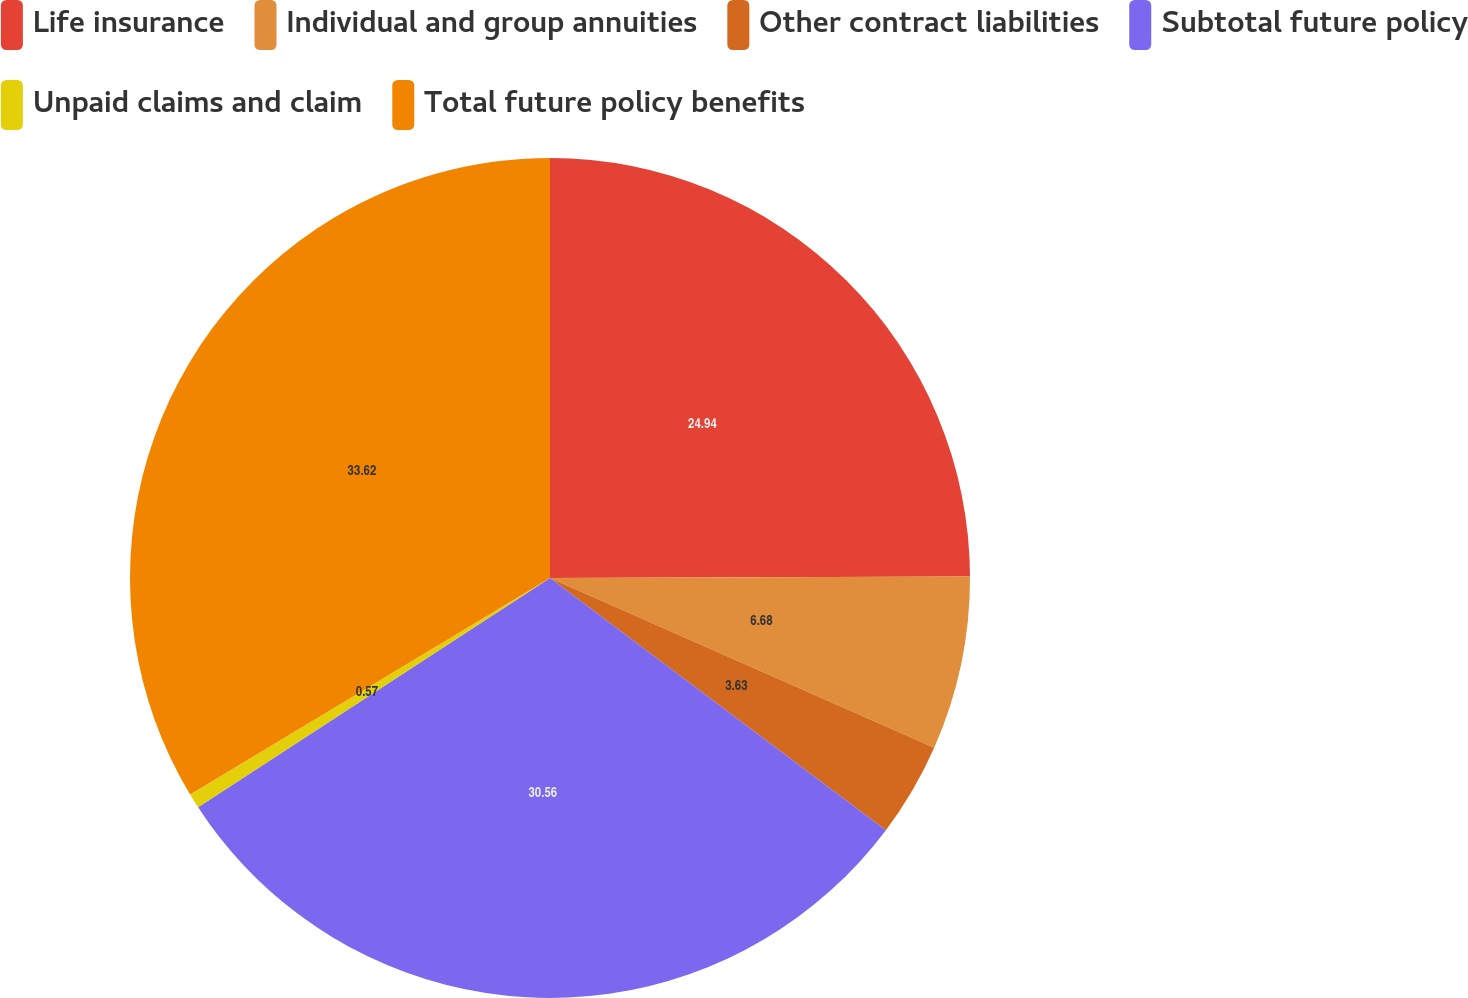Convert chart. <chart><loc_0><loc_0><loc_500><loc_500><pie_chart><fcel>Life insurance<fcel>Individual and group annuities<fcel>Other contract liabilities<fcel>Subtotal future policy<fcel>Unpaid claims and claim<fcel>Total future policy benefits<nl><fcel>24.94%<fcel>6.68%<fcel>3.63%<fcel>30.56%<fcel>0.57%<fcel>33.62%<nl></chart> 